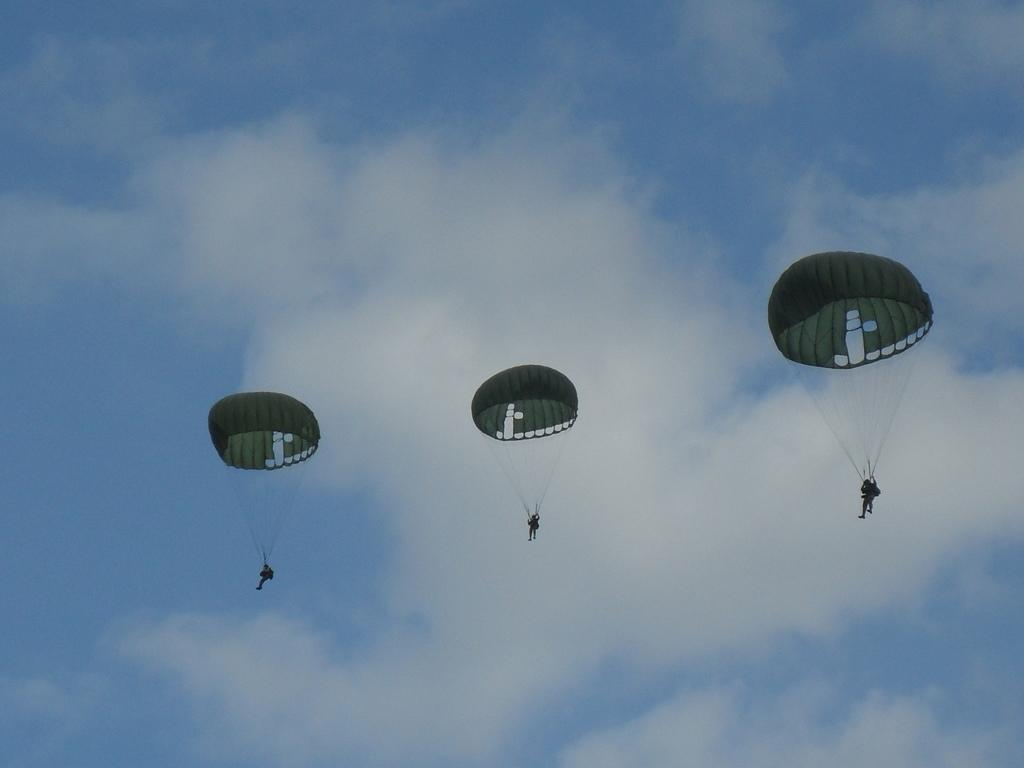What activity are the people in the image engaged in? The people in the image are parachuting. What can be seen in the background of the image? The sky is visible in the background of the image. What is the condition of the sky in the image? Clouds are present in the sky. What degree of difficulty is the parachuting course in the image? There is no indication of a parachuting course or its difficulty level in the image. How many apples are being used by the parachuters in the image? There are no apples present in the image. 